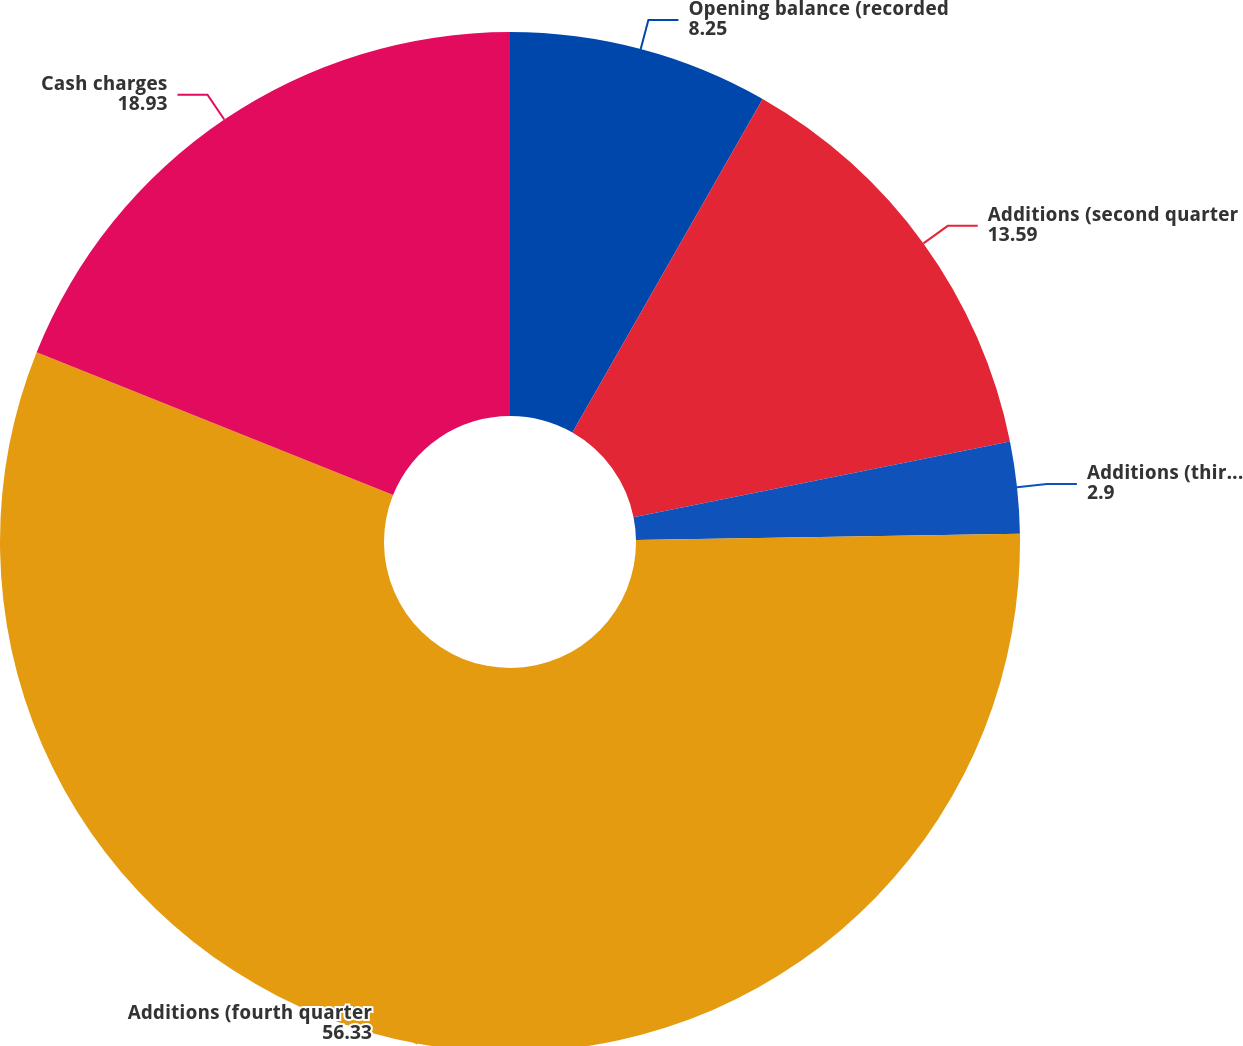Convert chart. <chart><loc_0><loc_0><loc_500><loc_500><pie_chart><fcel>Opening balance (recorded<fcel>Additions (second quarter<fcel>Additions (third quarter 2008)<fcel>Additions (fourth quarter<fcel>Cash charges<nl><fcel>8.25%<fcel>13.59%<fcel>2.9%<fcel>56.33%<fcel>18.93%<nl></chart> 